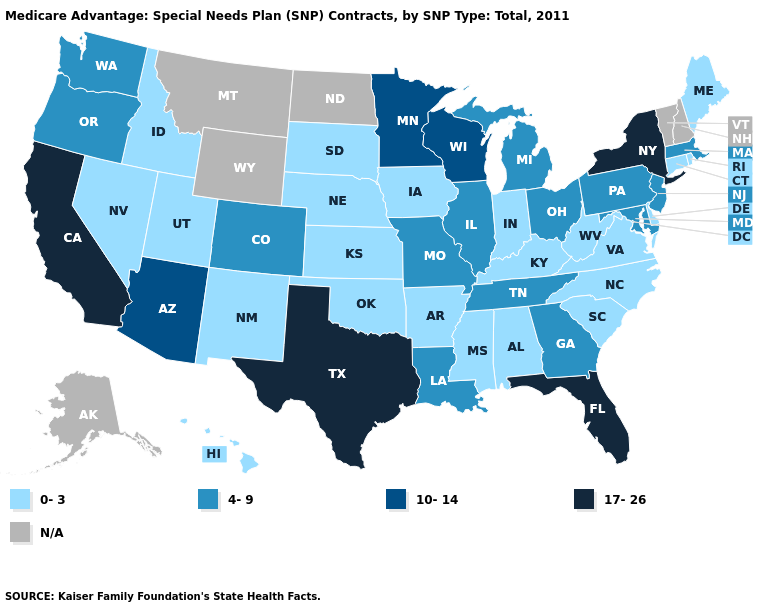What is the value of Kentucky?
Short answer required. 0-3. Among the states that border Georgia , does Florida have the highest value?
Answer briefly. Yes. Does Texas have the lowest value in the USA?
Answer briefly. No. What is the lowest value in states that border West Virginia?
Write a very short answer. 0-3. Which states have the lowest value in the West?
Be succinct. Hawaii, Idaho, New Mexico, Nevada, Utah. Name the states that have a value in the range 17-26?
Keep it brief. California, Florida, New York, Texas. Name the states that have a value in the range N/A?
Concise answer only. Alaska, Montana, North Dakota, New Hampshire, Vermont, Wyoming. Does the map have missing data?
Concise answer only. Yes. Which states have the lowest value in the MidWest?
Short answer required. Iowa, Indiana, Kansas, Nebraska, South Dakota. What is the highest value in states that border Mississippi?
Give a very brief answer. 4-9. Name the states that have a value in the range N/A?
Write a very short answer. Alaska, Montana, North Dakota, New Hampshire, Vermont, Wyoming. What is the lowest value in states that border Alabama?
Answer briefly. 0-3. What is the value of Nebraska?
Write a very short answer. 0-3. Among the states that border Illinois , which have the highest value?
Concise answer only. Wisconsin. What is the value of Maryland?
Write a very short answer. 4-9. 